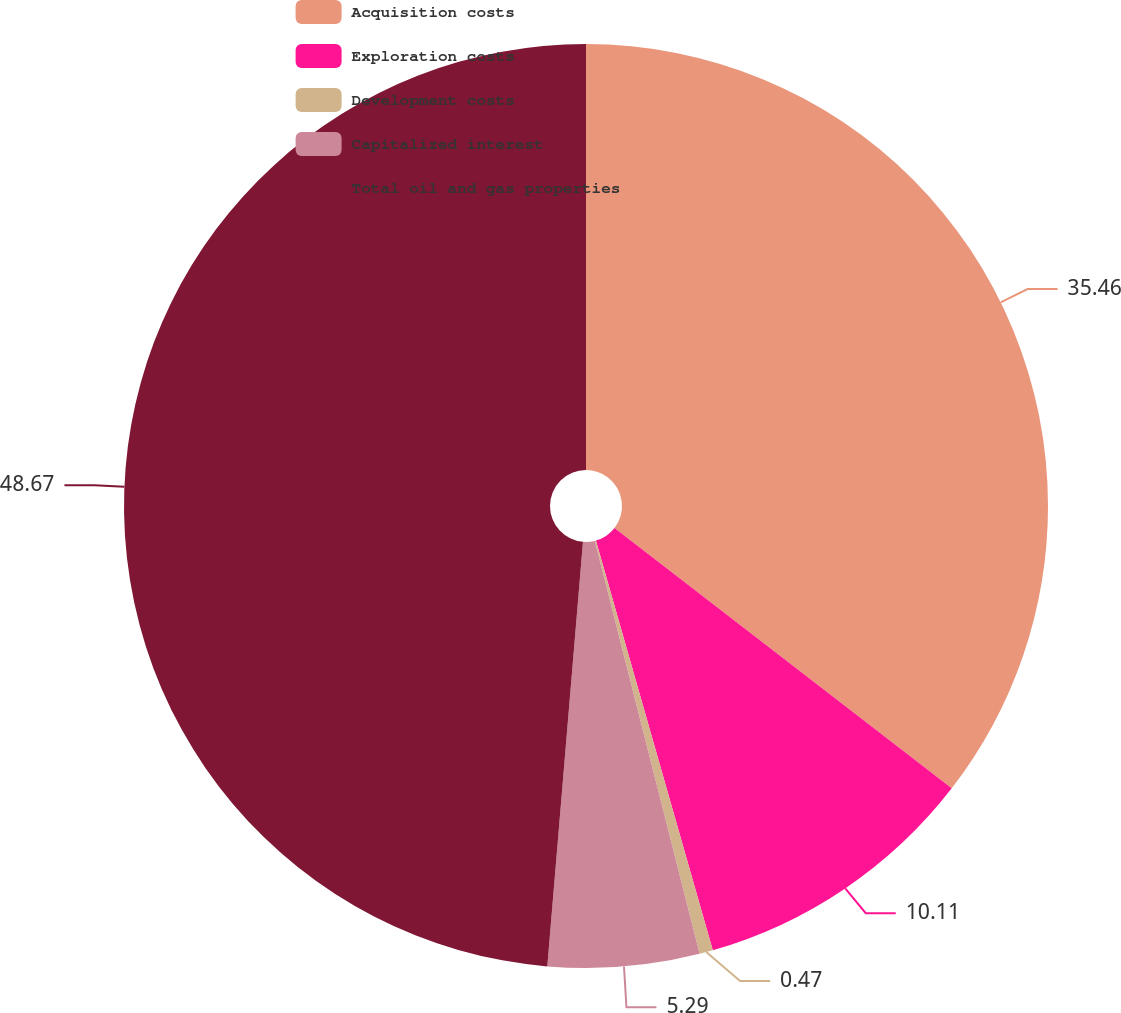Convert chart. <chart><loc_0><loc_0><loc_500><loc_500><pie_chart><fcel>Acquisition costs<fcel>Exploration costs<fcel>Development costs<fcel>Capitalized interest<fcel>Total oil and gas properties<nl><fcel>35.46%<fcel>10.11%<fcel>0.47%<fcel>5.29%<fcel>48.66%<nl></chart> 